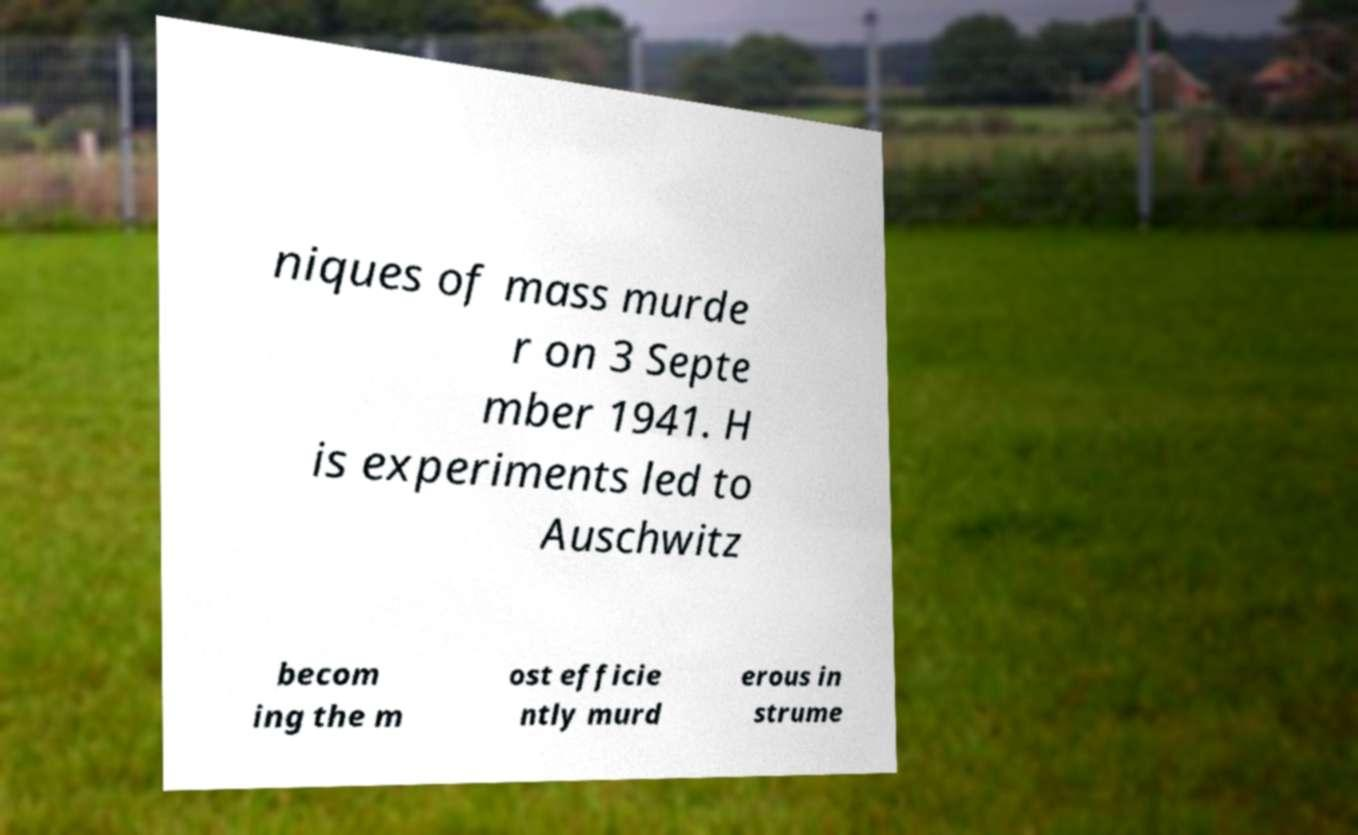Can you read and provide the text displayed in the image?This photo seems to have some interesting text. Can you extract and type it out for me? niques of mass murde r on 3 Septe mber 1941. H is experiments led to Auschwitz becom ing the m ost efficie ntly murd erous in strume 